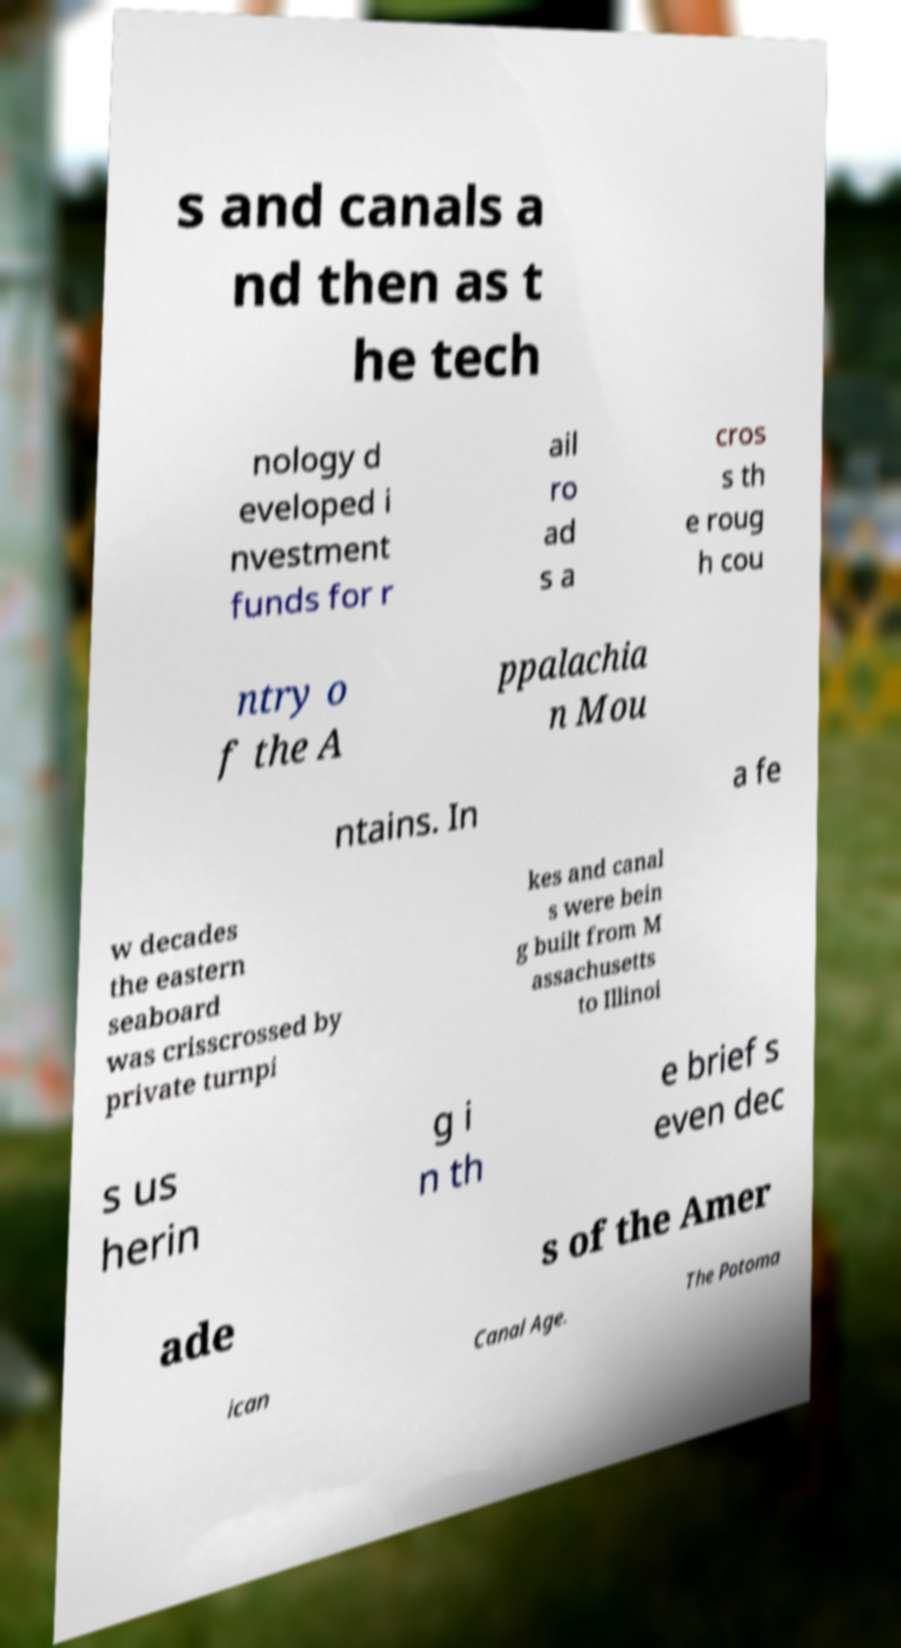There's text embedded in this image that I need extracted. Can you transcribe it verbatim? s and canals a nd then as t he tech nology d eveloped i nvestment funds for r ail ro ad s a cros s th e roug h cou ntry o f the A ppalachia n Mou ntains. In a fe w decades the eastern seaboard was crisscrossed by private turnpi kes and canal s were bein g built from M assachusetts to Illinoi s us herin g i n th e brief s even dec ade s of the Amer ican Canal Age. The Potoma 